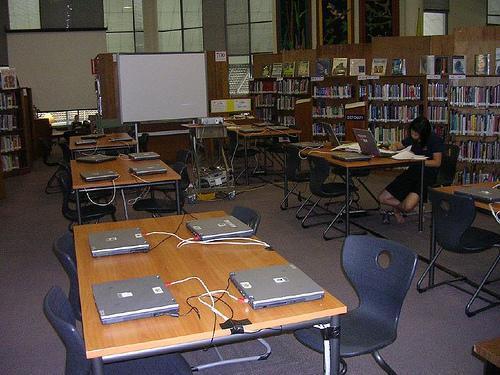How many people are visible?
Give a very brief answer. 1. 